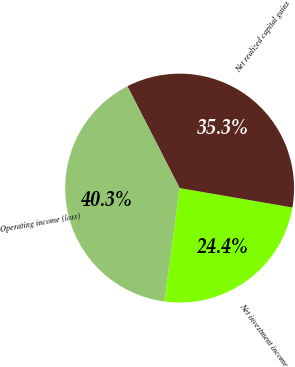Convert chart to OTSL. <chart><loc_0><loc_0><loc_500><loc_500><pie_chart><fcel>Net investment income<fcel>Net realized capital gains<fcel>Operating income (loss)<nl><fcel>24.41%<fcel>35.26%<fcel>40.33%<nl></chart> 